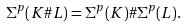<formula> <loc_0><loc_0><loc_500><loc_500>\Sigma ^ { p } ( K \# L ) = \Sigma ^ { p } ( K ) \# \Sigma ^ { p } ( L ) .</formula> 